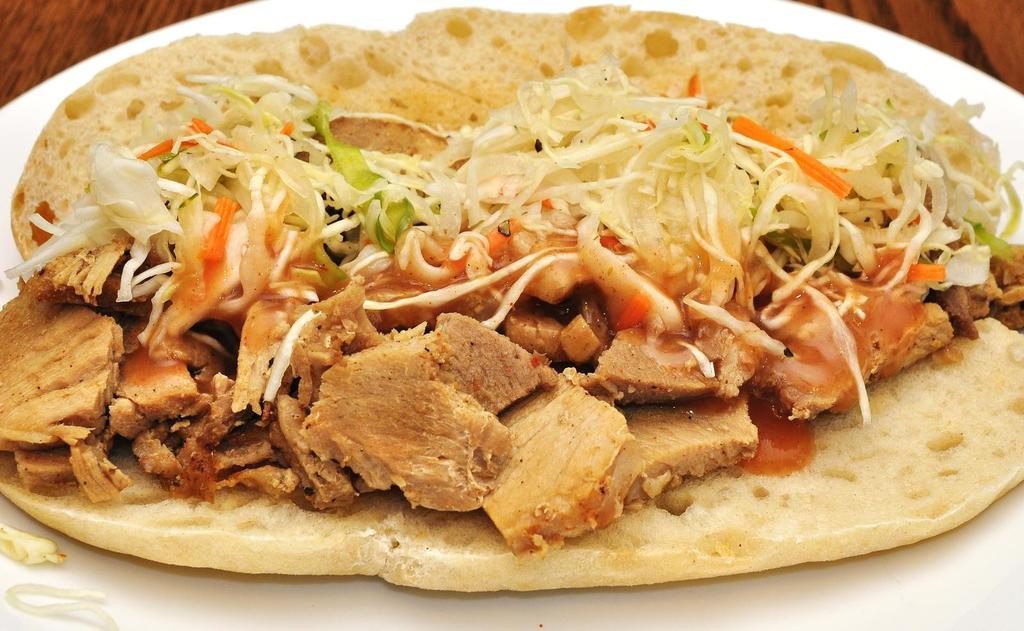What type of food is visible in the image? There is a sandwich in the image. Where is the sandwich located? The sandwich is placed on a plate. Is there a volcano erupting in the background of the image? No, there is no volcano or any indication of an eruption in the image. 